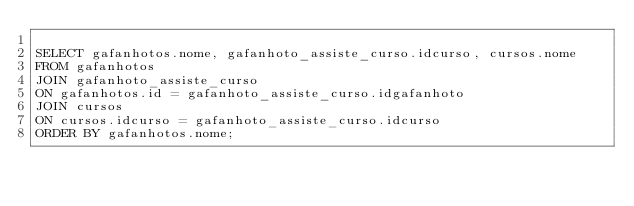<code> <loc_0><loc_0><loc_500><loc_500><_SQL_>
SELECT gafanhotos.nome, gafanhoto_assiste_curso.idcurso, cursos.nome
FROM gafanhotos
JOIN gafanhoto_assiste_curso
ON gafanhotos.id = gafanhoto_assiste_curso.idgafanhoto
JOIN cursos
ON cursos.idcurso = gafanhoto_assiste_curso.idcurso
ORDER BY gafanhotos.nome;</code> 